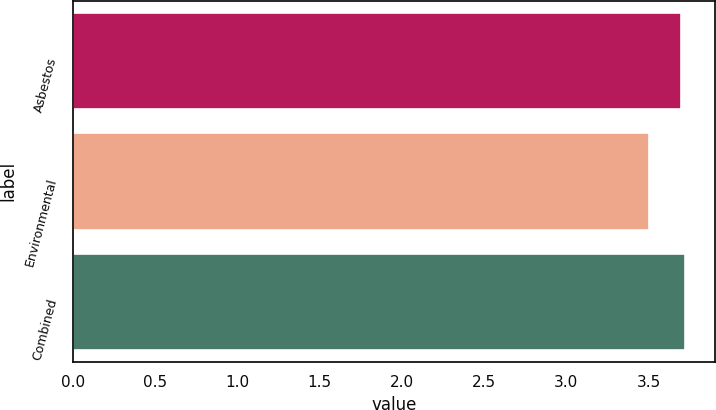<chart> <loc_0><loc_0><loc_500><loc_500><bar_chart><fcel>Asbestos<fcel>Environmental<fcel>Combined<nl><fcel>3.7<fcel>3.5<fcel>3.72<nl></chart> 